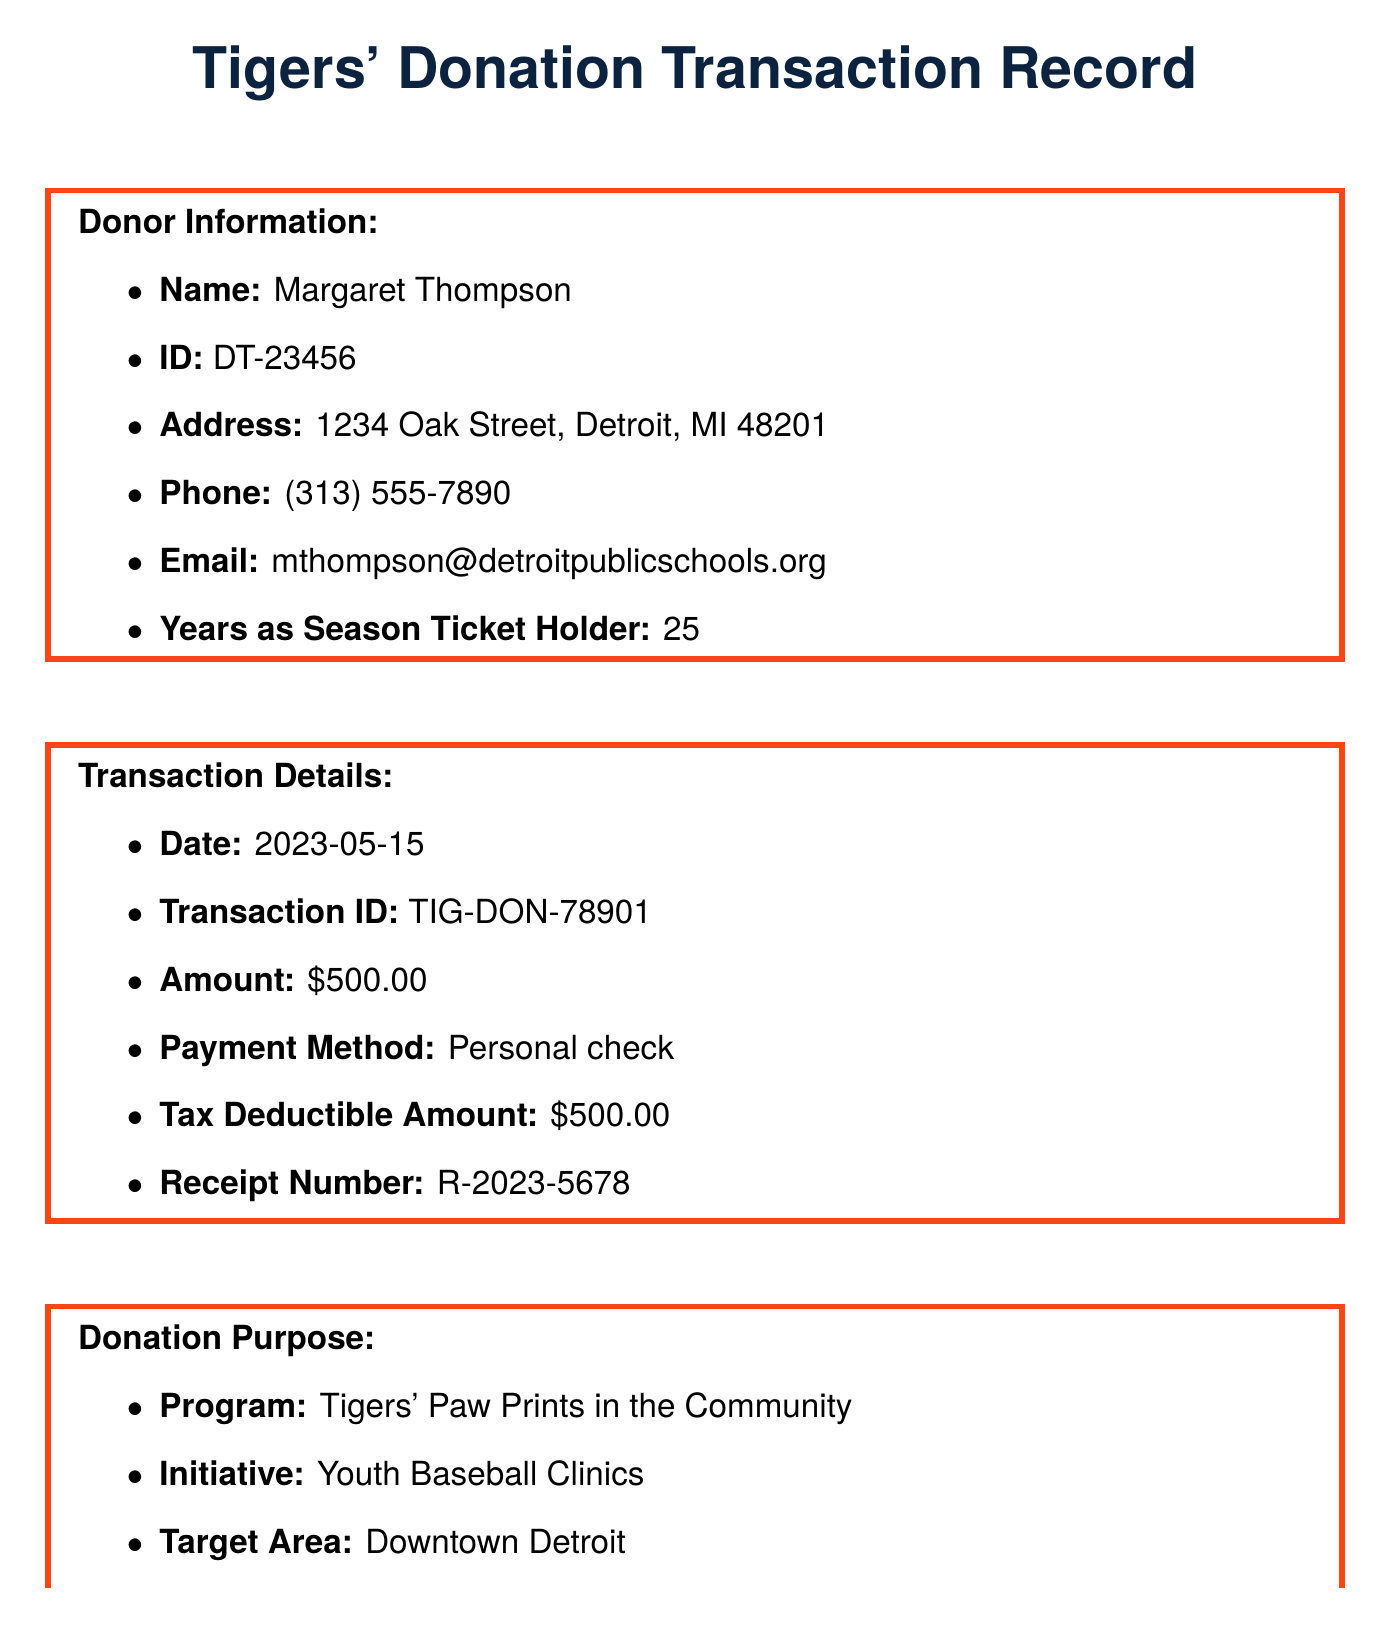What is the name of the donor? The document specifically lists the donor's name as Margaret Thompson.
Answer: Margaret Thompson What was the donation amount? The amount of the donation mentioned in the document is $500.00.
Answer: $500.00 What is the transaction date? The date when the transaction took place is provided as May 15, 2023.
Answer: 2023-05-15 What is the purpose of the donation? The document indicates that the donation is for the Tigers' Paw Prints in the Community program.
Answer: Tigers' Paw Prints in the Community How many years has the donor been a season ticket holder? The document states that the donor has been a season ticket holder for 25 years.
Answer: 25 What is the expected reach of the youth clinics? The expected reach mentioned is for 200 children aged 8-14.
Answer: 200 children Who is the contact person for the Tigers' community outreach? The document identifies Sarah Johnson as the Community Outreach Coordinator.
Answer: Sarah Johnson What will the donor receive as special recognition? According to the document, the donor will be acknowledged on the Tigers' Community Partners wall at Comerica Park.
Answer: Acknowledged on the Tigers' Community Partners wall at Comerica Park What is the duration of the youth baseball clinics? The document specifies that the clinics will run during Summer 2023 from June to August.
Answer: Summer 2023 (June - August) 